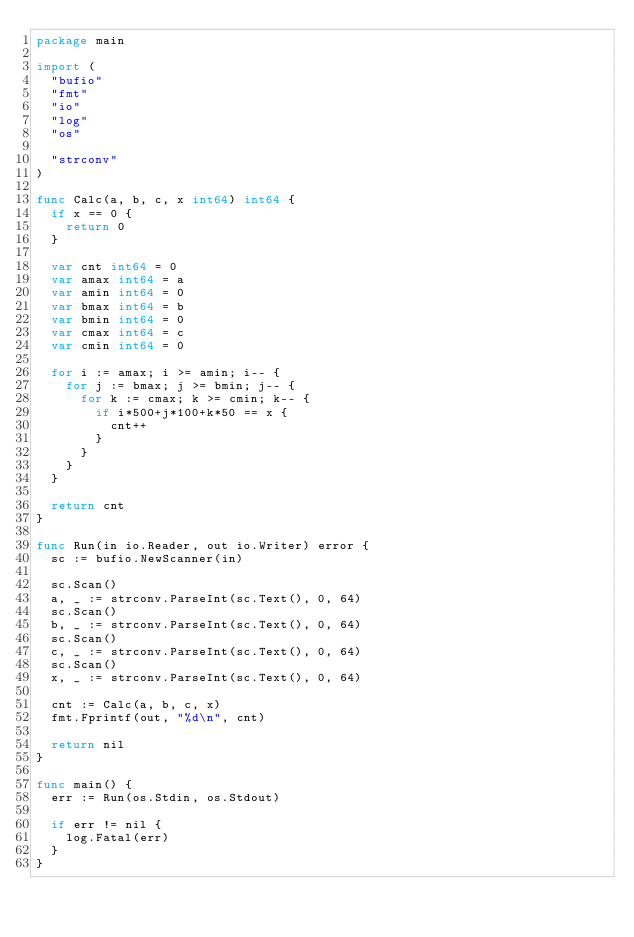Convert code to text. <code><loc_0><loc_0><loc_500><loc_500><_Go_>package main

import (
	"bufio"
	"fmt"
	"io"
	"log"
	"os"

	"strconv"
)

func Calc(a, b, c, x int64) int64 {
	if x == 0 {
		return 0
	}

	var cnt int64 = 0
	var amax int64 = a
	var amin int64 = 0
	var bmax int64 = b
	var bmin int64 = 0
	var cmax int64 = c
	var cmin int64 = 0

	for i := amax; i >= amin; i-- {
		for j := bmax; j >= bmin; j-- {
			for k := cmax; k >= cmin; k-- {
				if i*500+j*100+k*50 == x {
					cnt++
				}
			}
		}
	}

	return cnt
}

func Run(in io.Reader, out io.Writer) error {
	sc := bufio.NewScanner(in)

	sc.Scan()
	a, _ := strconv.ParseInt(sc.Text(), 0, 64)
	sc.Scan()
	b, _ := strconv.ParseInt(sc.Text(), 0, 64)
	sc.Scan()
	c, _ := strconv.ParseInt(sc.Text(), 0, 64)
	sc.Scan()
	x, _ := strconv.ParseInt(sc.Text(), 0, 64)

	cnt := Calc(a, b, c, x)
	fmt.Fprintf(out, "%d\n", cnt)

	return nil
}

func main() {
	err := Run(os.Stdin, os.Stdout)

	if err != nil {
		log.Fatal(err)
	}
}
</code> 